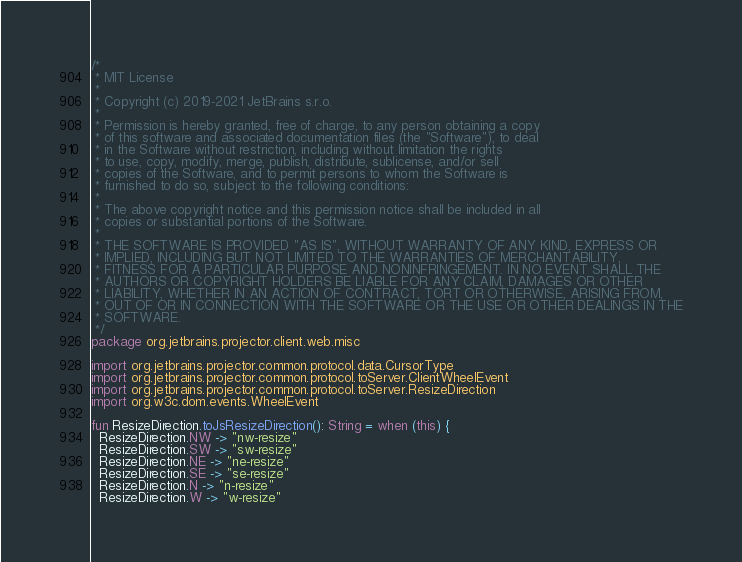Convert code to text. <code><loc_0><loc_0><loc_500><loc_500><_Kotlin_>/*
 * MIT License
 *
 * Copyright (c) 2019-2021 JetBrains s.r.o.
 *
 * Permission is hereby granted, free of charge, to any person obtaining a copy
 * of this software and associated documentation files (the "Software"), to deal
 * in the Software without restriction, including without limitation the rights
 * to use, copy, modify, merge, publish, distribute, sublicense, and/or sell
 * copies of the Software, and to permit persons to whom the Software is
 * furnished to do so, subject to the following conditions:
 *
 * The above copyright notice and this permission notice shall be included in all
 * copies or substantial portions of the Software.
 *
 * THE SOFTWARE IS PROVIDED "AS IS", WITHOUT WARRANTY OF ANY KIND, EXPRESS OR
 * IMPLIED, INCLUDING BUT NOT LIMITED TO THE WARRANTIES OF MERCHANTABILITY,
 * FITNESS FOR A PARTICULAR PURPOSE AND NONINFRINGEMENT. IN NO EVENT SHALL THE
 * AUTHORS OR COPYRIGHT HOLDERS BE LIABLE FOR ANY CLAIM, DAMAGES OR OTHER
 * LIABILITY, WHETHER IN AN ACTION OF CONTRACT, TORT OR OTHERWISE, ARISING FROM,
 * OUT OF OR IN CONNECTION WITH THE SOFTWARE OR THE USE OR OTHER DEALINGS IN THE
 * SOFTWARE.
 */
package org.jetbrains.projector.client.web.misc

import org.jetbrains.projector.common.protocol.data.CursorType
import org.jetbrains.projector.common.protocol.toServer.ClientWheelEvent
import org.jetbrains.projector.common.protocol.toServer.ResizeDirection
import org.w3c.dom.events.WheelEvent

fun ResizeDirection.toJsResizeDirection(): String = when (this) {
  ResizeDirection.NW -> "nw-resize"
  ResizeDirection.SW -> "sw-resize"
  ResizeDirection.NE -> "ne-resize"
  ResizeDirection.SE -> "se-resize"
  ResizeDirection.N -> "n-resize"
  ResizeDirection.W -> "w-resize"</code> 